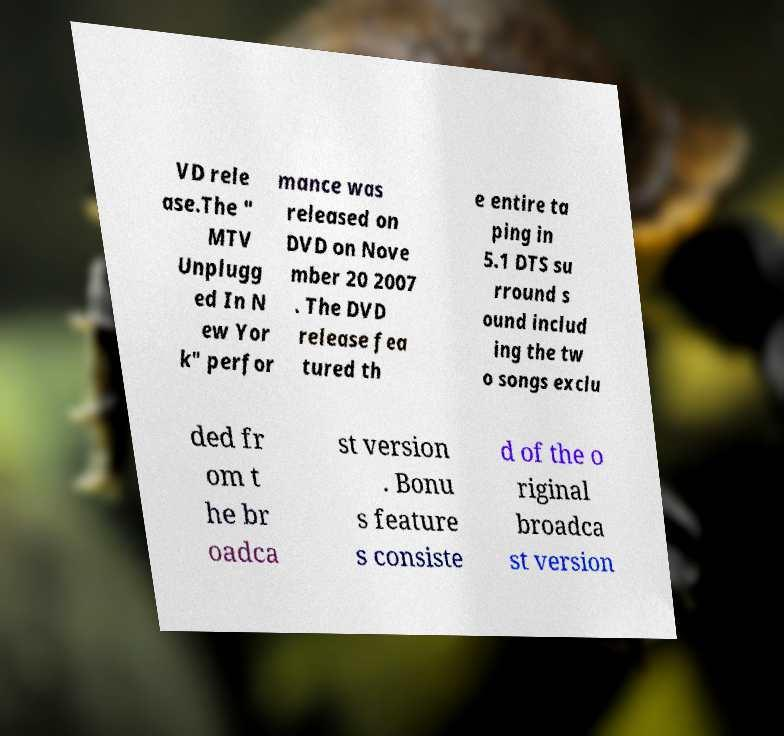For documentation purposes, I need the text within this image transcribed. Could you provide that? VD rele ase.The " MTV Unplugg ed In N ew Yor k" perfor mance was released on DVD on Nove mber 20 2007 . The DVD release fea tured th e entire ta ping in 5.1 DTS su rround s ound includ ing the tw o songs exclu ded fr om t he br oadca st version . Bonu s feature s consiste d of the o riginal broadca st version 